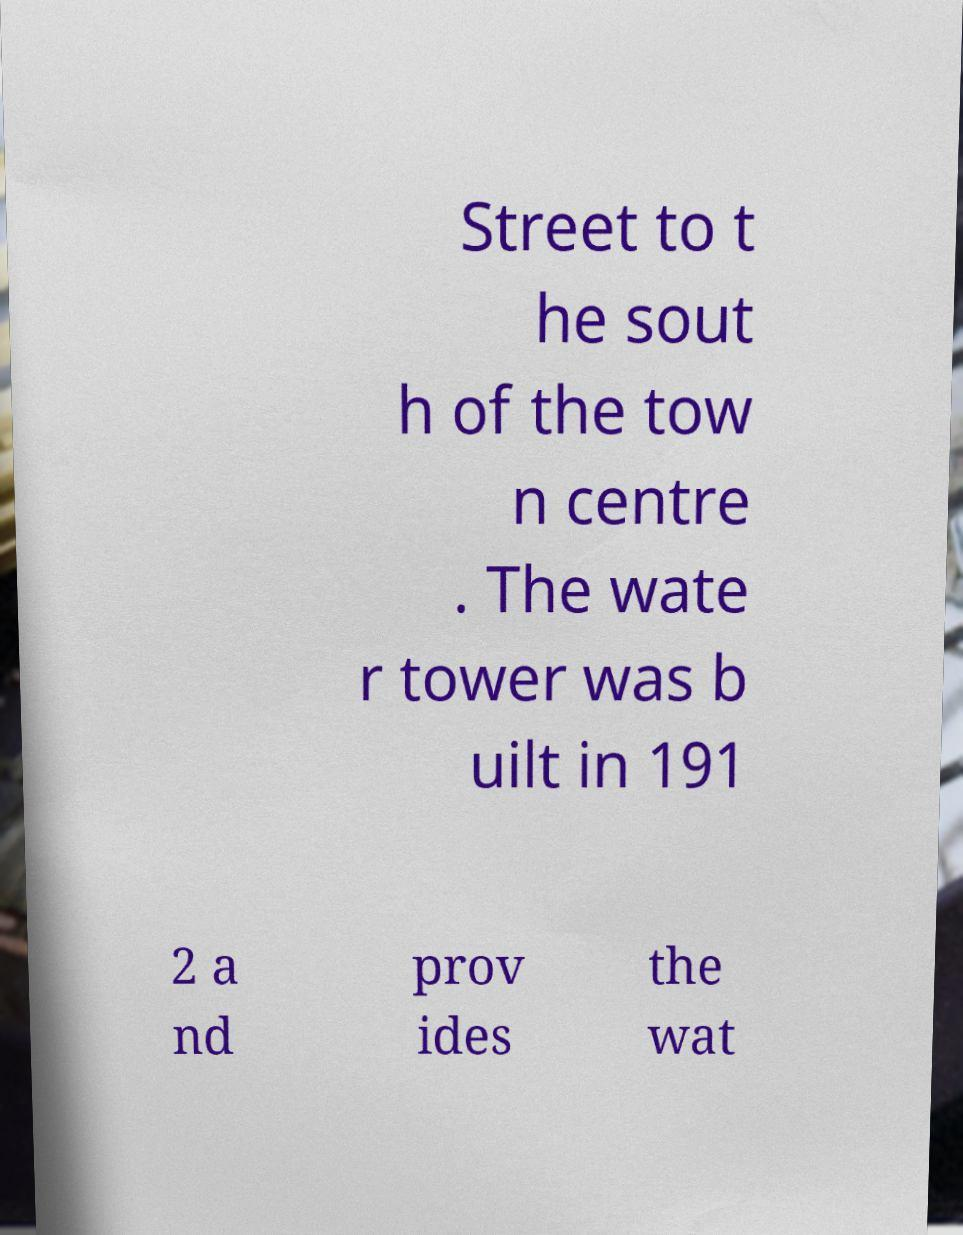Please read and relay the text visible in this image. What does it say? Street to t he sout h of the tow n centre . The wate r tower was b uilt in 191 2 a nd prov ides the wat 